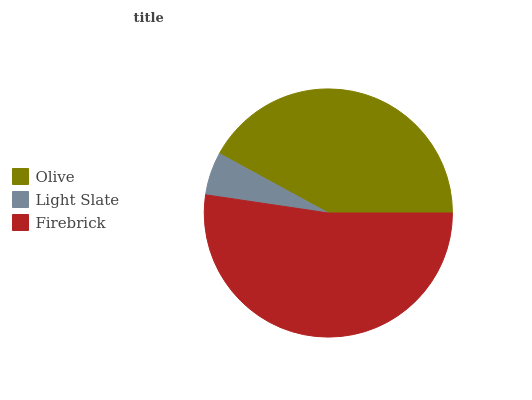Is Light Slate the minimum?
Answer yes or no. Yes. Is Firebrick the maximum?
Answer yes or no. Yes. Is Firebrick the minimum?
Answer yes or no. No. Is Light Slate the maximum?
Answer yes or no. No. Is Firebrick greater than Light Slate?
Answer yes or no. Yes. Is Light Slate less than Firebrick?
Answer yes or no. Yes. Is Light Slate greater than Firebrick?
Answer yes or no. No. Is Firebrick less than Light Slate?
Answer yes or no. No. Is Olive the high median?
Answer yes or no. Yes. Is Olive the low median?
Answer yes or no. Yes. Is Light Slate the high median?
Answer yes or no. No. Is Firebrick the low median?
Answer yes or no. No. 